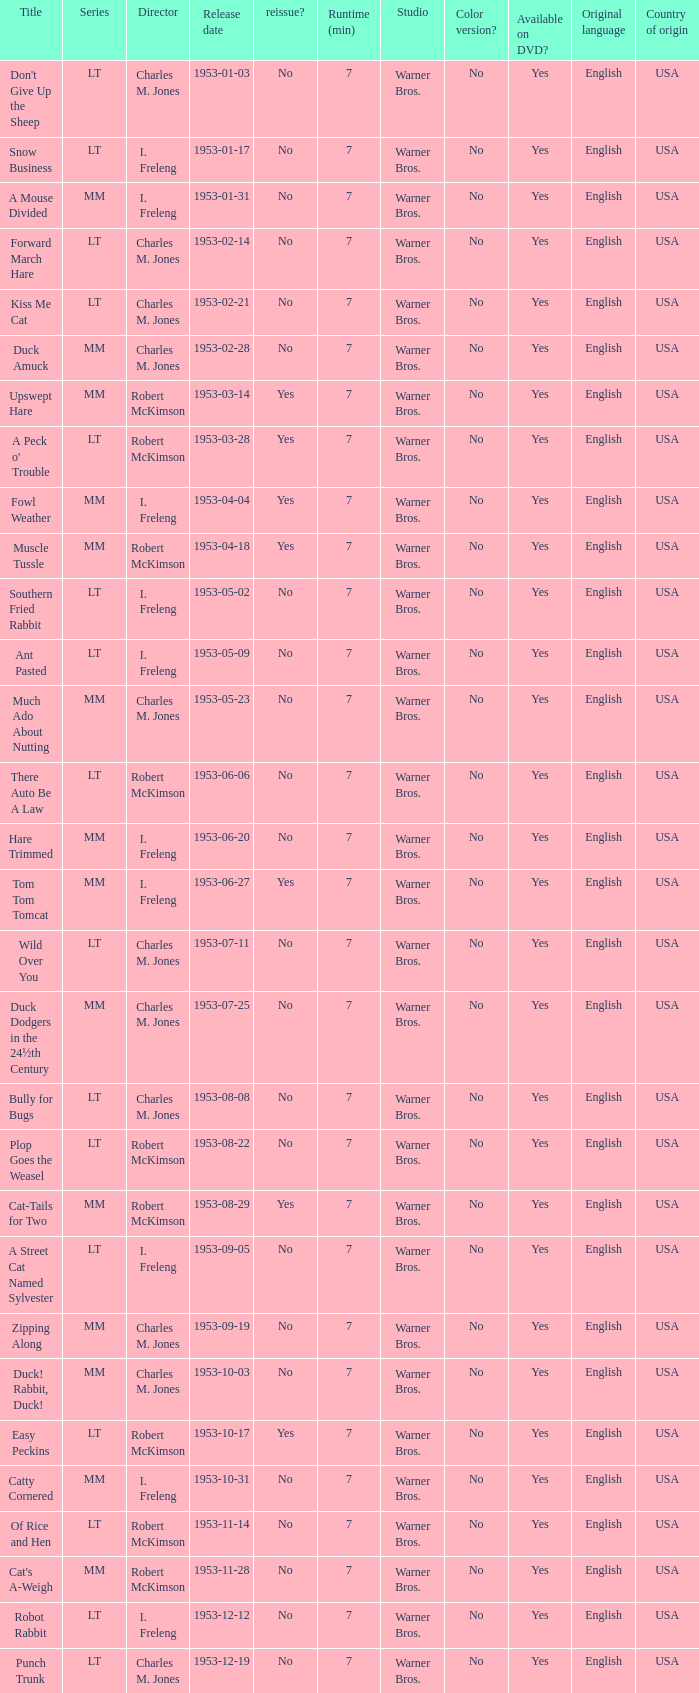What's the release date of Forward March Hare? 1953-02-14. 